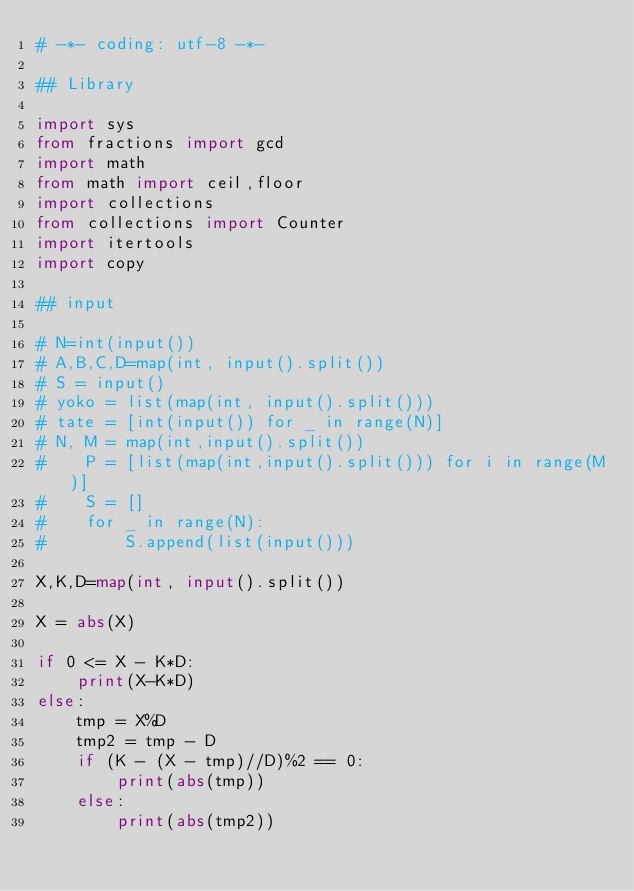<code> <loc_0><loc_0><loc_500><loc_500><_Python_># -*- coding: utf-8 -*-
 
## Library
 
import sys
from fractions import gcd
import math
from math import ceil,floor
import collections
from collections import Counter
import itertools
import copy

## input
 
# N=int(input())
# A,B,C,D=map(int, input().split())
# S = input()
# yoko = list(map(int, input().split()))
# tate = [int(input()) for _ in range(N)]
# N, M = map(int,input().split()) 
#    P = [list(map(int,input().split())) for i in range(M)]
#    S = []
#    for _ in range(N):
#        S.append(list(input()))

X,K,D=map(int, input().split())

X = abs(X)

if 0 <= X - K*D:
    print(X-K*D)
else:
    tmp = X%D
    tmp2 = tmp - D
    if (K - (X - tmp)//D)%2 == 0:
        print(abs(tmp))
    else:
        print(abs(tmp2))
</code> 